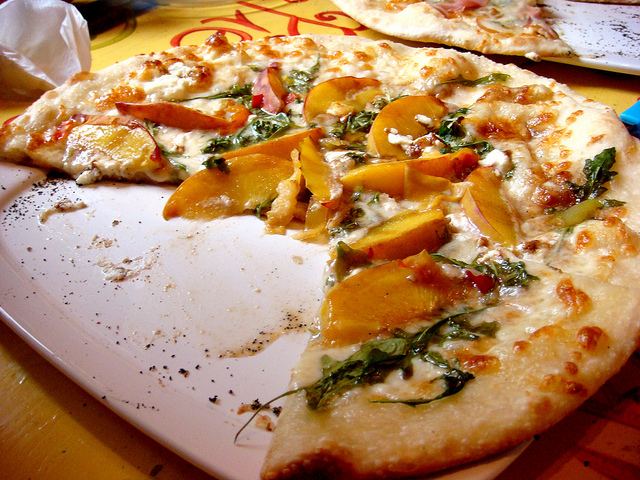Can you tell me about the setting where this food is being eaten? The food is positioned on a white plate that rests directly on a wooden table, suggesting a casual dining environment. The presence of crumbs and little bits of toppings scattered on the plate implies an ongoing meal, emphasizing a relaxed and perhaps convivial setting. 